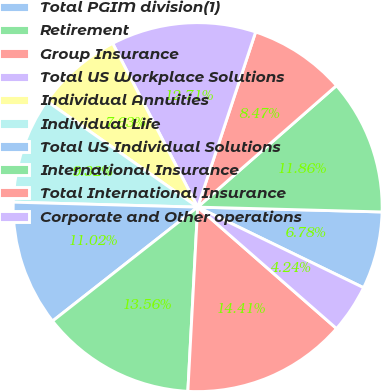Convert chart to OTSL. <chart><loc_0><loc_0><loc_500><loc_500><pie_chart><fcel>Total PGIM division(1)<fcel>Retirement<fcel>Group Insurance<fcel>Total US Workplace Solutions<fcel>Individual Annuities<fcel>Individual Life<fcel>Total US Individual Solutions<fcel>International Insurance<fcel>Total International Insurance<fcel>Corporate and Other operations<nl><fcel>6.78%<fcel>11.86%<fcel>8.47%<fcel>12.71%<fcel>7.63%<fcel>9.32%<fcel>11.02%<fcel>13.56%<fcel>14.41%<fcel>4.24%<nl></chart> 